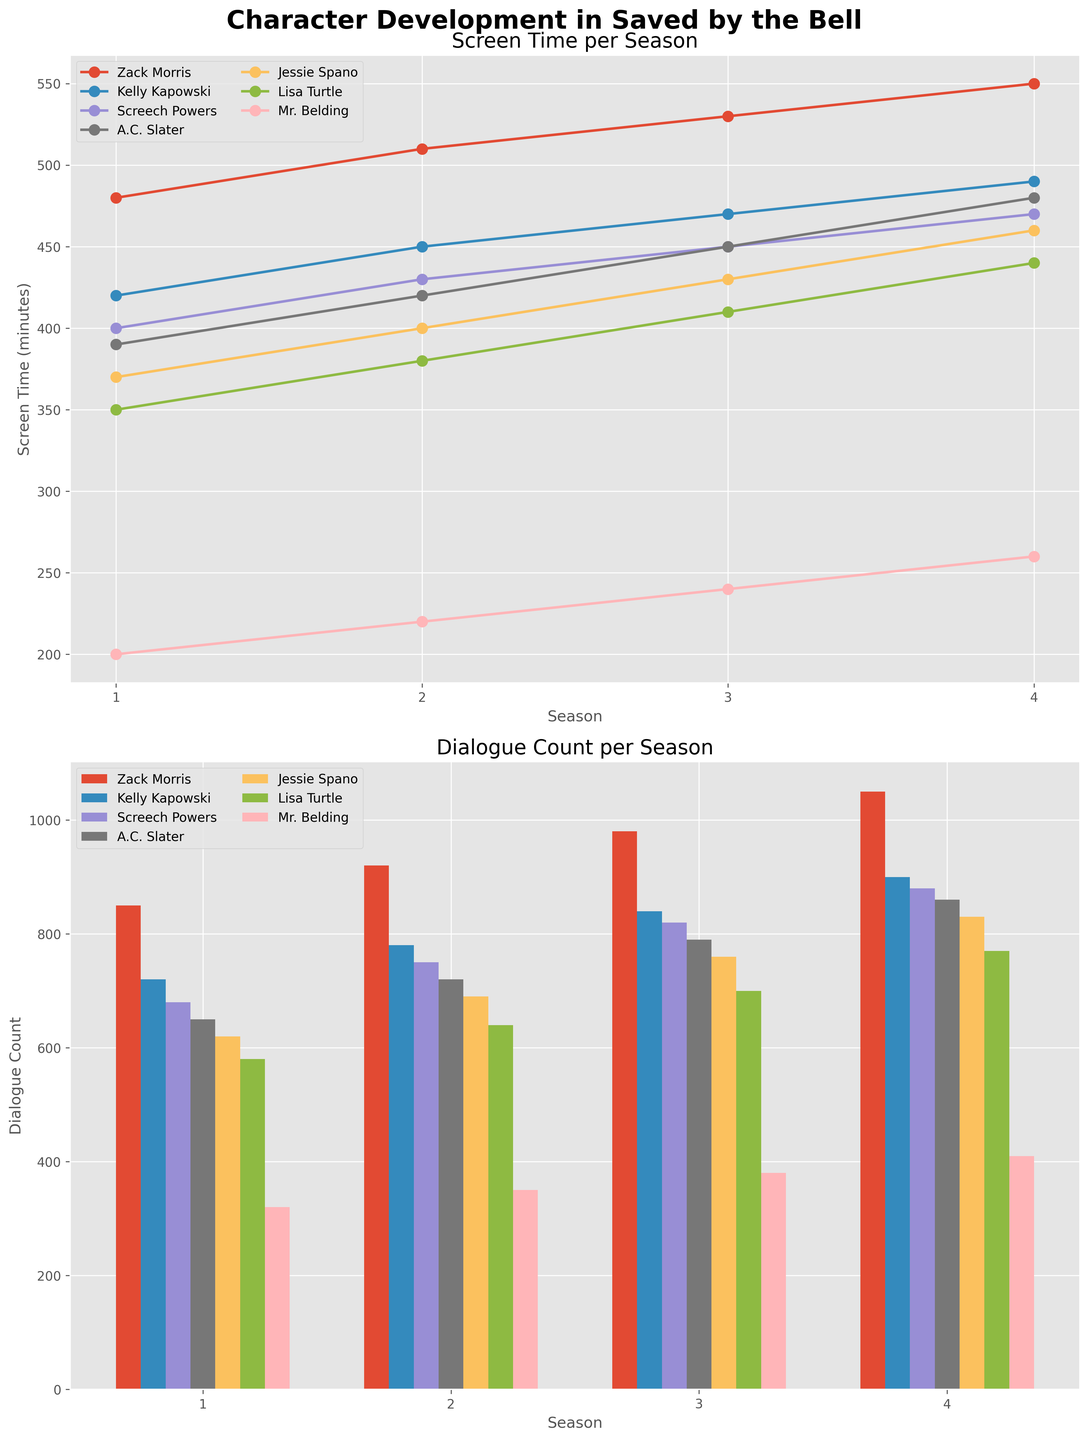Which character has the most screen time in Season 2? Look at the line plot in the subplot for screen time and identify the character with the highest value for Season 2.
Answer: Zack Morris How does Kelly Kapowski's dialogue count in Season 3 compare to Zack Morris's? Refer to the bar plot for dialogue count and compare the heights of the bars for Kelly Kapowski and Zack Morris in Season 3.
Answer: Lower What is the total screen time for Mr. Belding across all seasons? Add up the screen time values for Mr. Belding from all seasons: 200 + 220 + 240 + 260.
Answer: 920 minutes Which character has the least dialogue count in Season 4? Look at the bars in the dialogue count subplot for Season 4 and find the shortest bar.
Answer: Mr. Belding What is the average screen time per season for Screech Powers? Sum up Screech Powers's screen time across all seasons (400 + 430 + 450 + 470) and divide by the number of seasons (4).
Answer: 437.5 minutes Compare the screen time trend of Zack Morris and Lisa Turtle. Who shows a steeper increase over the seasons? Compare the slopes of the lines for Zack Morris and Lisa Turtle in the screen time subplot. Zack Morris's line is steeper.
Answer: Zack Morris How many more lines of dialogue does A.C. Slater have in Season 3 compared to Season 1? Subtract A.C. Slater's dialogue count in Season 1 from his count in Season 3: 790 - 650.
Answer: 140 lines Which character had the most significant increase in screen time from Season 1 to Season 2? Calculate the differences between Season 1 and Season 2 screen times for each character, and find the largest difference. Zack Morris: 30, Kelly Kapowski: 30, Screech Powers: 30, A.C. Slater: 30, Jessie Spano: 30, Lisa Turtle: 30, Mr. Belding: 20.
Answer: Zack Morris, Kelly Kapowski, Screech Powers, A.C. Slater, Jessie Spano, and Lisa Turtle (all had an increase of 30 minutes) What is the total dialogue count for all characters in Season 2? Add up the dialogue counts for all characters in Season 2: 920 + 780 + 750 + 720 + 690 + 640 + 350.
Answer: 4,850 lines 